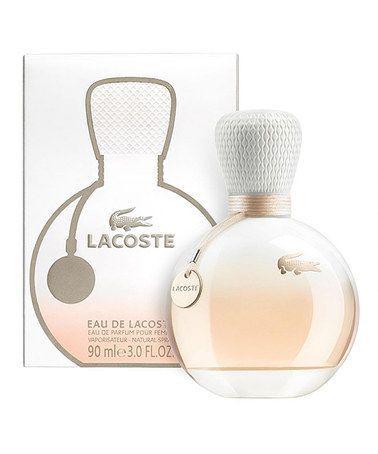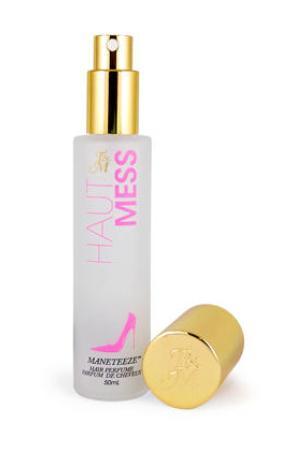The first image is the image on the left, the second image is the image on the right. Assess this claim about the two images: "There is at least one bottle of perfume being displayed in the center of both images.". Correct or not? Answer yes or no. Yes. The first image is the image on the left, the second image is the image on the right. Evaluate the accuracy of this statement regarding the images: "In at least one image there are at least two bottle of perfume and at least one box". Is it true? Answer yes or no. No. 